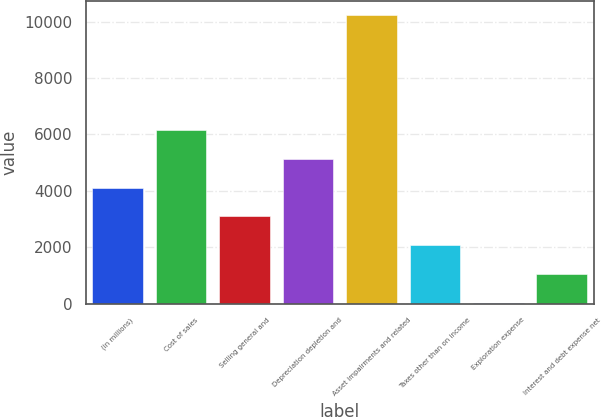<chart> <loc_0><loc_0><loc_500><loc_500><bar_chart><fcel>(in millions)<fcel>Cost of sales<fcel>Selling general and<fcel>Depreciation depletion and<fcel>Asset impairments and related<fcel>Taxes other than on income<fcel>Exploration expense<fcel>Interest and debt expense net<nl><fcel>4117.2<fcel>6157.8<fcel>3096.9<fcel>5137.5<fcel>10239<fcel>2076.6<fcel>36<fcel>1056.3<nl></chart> 